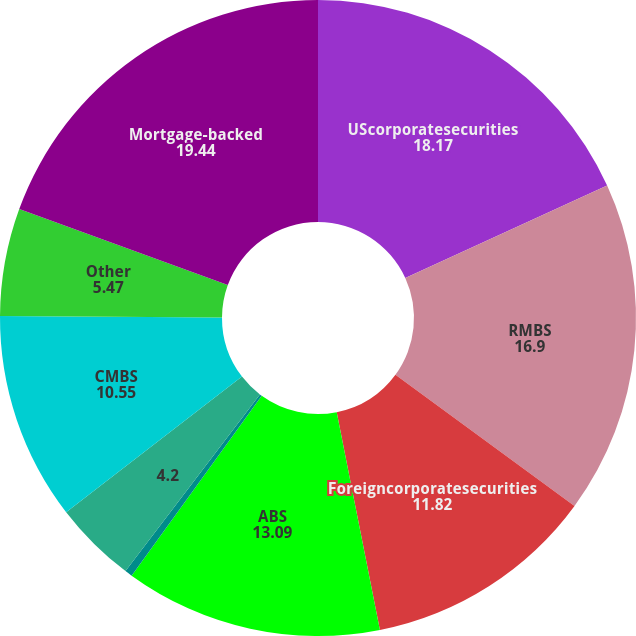Convert chart. <chart><loc_0><loc_0><loc_500><loc_500><pie_chart><fcel>UScorporatesecurities<fcel>RMBS<fcel>Foreigncorporatesecurities<fcel>ABS<fcel>Foreigngovernmentsecurities<fcel>Unnamed: 5<fcel>CMBS<fcel>Other<fcel>Mortgage-backed<nl><fcel>18.17%<fcel>16.9%<fcel>11.82%<fcel>13.09%<fcel>0.38%<fcel>4.2%<fcel>10.55%<fcel>5.47%<fcel>19.44%<nl></chart> 